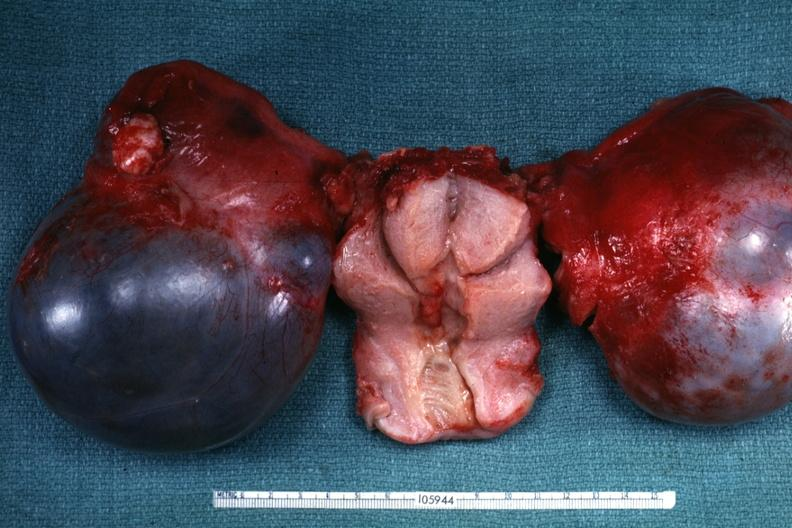s serous cystadenoma present?
Answer the question using a single word or phrase. Yes 